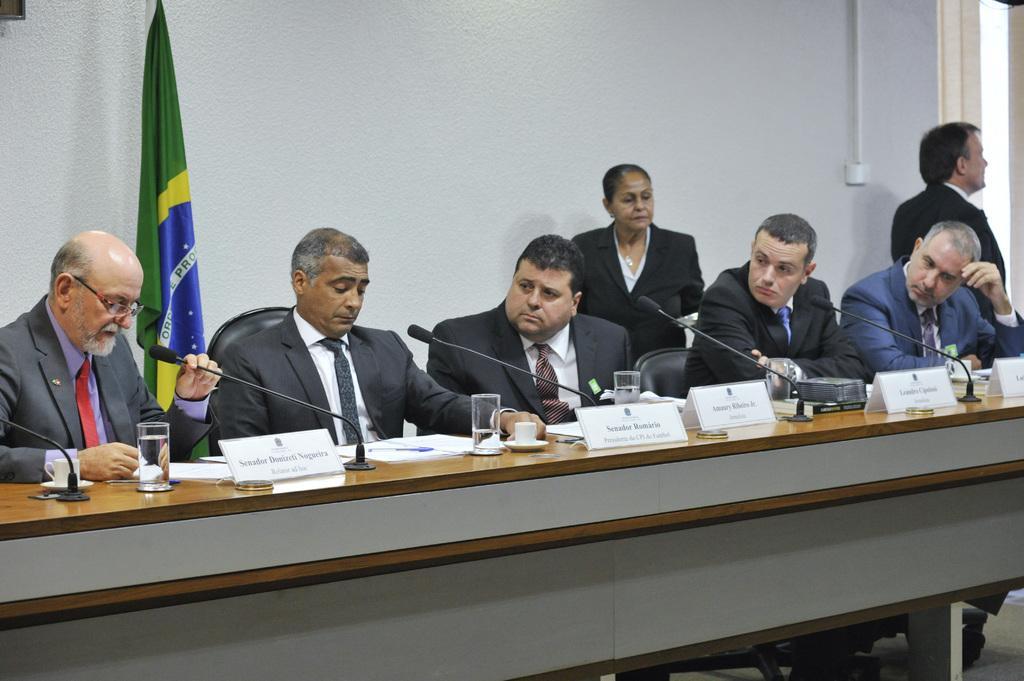Can you describe this image briefly? In the picture we can find some people sitting, two people are standing, persons who are sitting on the chairs near the desk are reading something on the papers. On the desk there are places with the glasses, cup and saucers. In the background we can find the flag and wall. 